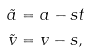<formula> <loc_0><loc_0><loc_500><loc_500>\tilde { a } & = a - s t \\ \tilde { v } & = v - s ,</formula> 